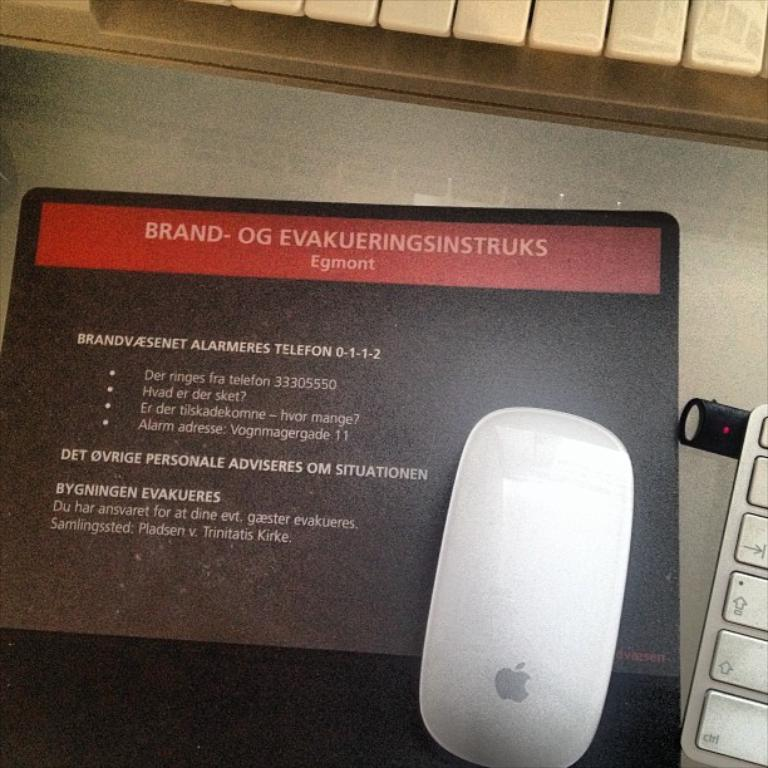What type of animal is in the image? There is a mouse in the image. What object is likely used with the mouse? There is a keyboard in the image. What surface is the mouse placed on? There is a mouse pad in the image. What can be seen on the mouse pad? There is something written on the mouse pad. What color is the paint on the nation's flag in the image? There is no mention of a nation or a flag in the image, so it is not possible to answer that question. 